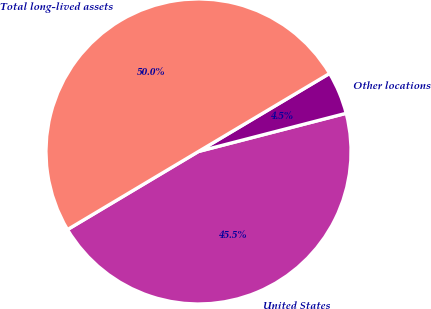Convert chart to OTSL. <chart><loc_0><loc_0><loc_500><loc_500><pie_chart><fcel>United States<fcel>Other locations<fcel>Total long-lived assets<nl><fcel>45.47%<fcel>4.52%<fcel>50.01%<nl></chart> 